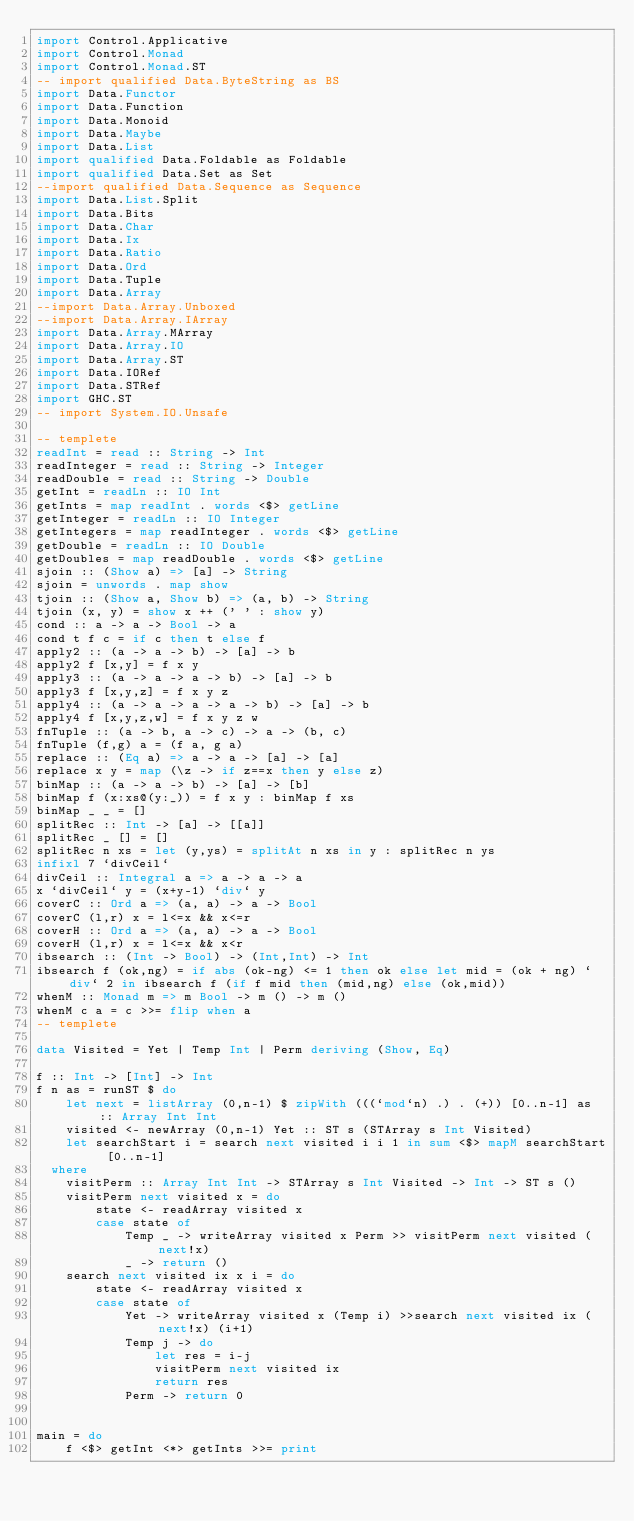Convert code to text. <code><loc_0><loc_0><loc_500><loc_500><_Haskell_>import Control.Applicative
import Control.Monad
import Control.Monad.ST
-- import qualified Data.ByteString as BS
import Data.Functor
import Data.Function
import Data.Monoid
import Data.Maybe
import Data.List
import qualified Data.Foldable as Foldable
import qualified Data.Set as Set
--import qualified Data.Sequence as Sequence
import Data.List.Split
import Data.Bits
import Data.Char
import Data.Ix
import Data.Ratio
import Data.Ord
import Data.Tuple
import Data.Array
--import Data.Array.Unboxed
--import Data.Array.IArray
import Data.Array.MArray
import Data.Array.IO
import Data.Array.ST
import Data.IORef
import Data.STRef
import GHC.ST
-- import System.IO.Unsafe
 
-- templete
readInt = read :: String -> Int
readInteger = read :: String -> Integer
readDouble = read :: String -> Double
getInt = readLn :: IO Int
getInts = map readInt . words <$> getLine
getInteger = readLn :: IO Integer
getIntegers = map readInteger . words <$> getLine
getDouble = readLn :: IO Double
getDoubles = map readDouble . words <$> getLine
sjoin :: (Show a) => [a] -> String
sjoin = unwords . map show
tjoin :: (Show a, Show b) => (a, b) -> String
tjoin (x, y) = show x ++ (' ' : show y)
cond :: a -> a -> Bool -> a
cond t f c = if c then t else f
apply2 :: (a -> a -> b) -> [a] -> b
apply2 f [x,y] = f x y
apply3 :: (a -> a -> a -> b) -> [a] -> b
apply3 f [x,y,z] = f x y z
apply4 :: (a -> a -> a -> a -> b) -> [a] -> b
apply4 f [x,y,z,w] = f x y z w
fnTuple :: (a -> b, a -> c) -> a -> (b, c)
fnTuple (f,g) a = (f a, g a)
replace :: (Eq a) => a -> a -> [a] -> [a]
replace x y = map (\z -> if z==x then y else z)
binMap :: (a -> a -> b) -> [a] -> [b]
binMap f (x:xs@(y:_)) = f x y : binMap f xs
binMap _ _ = []
splitRec :: Int -> [a] -> [[a]]
splitRec _ [] = []
splitRec n xs = let (y,ys) = splitAt n xs in y : splitRec n ys
infixl 7 `divCeil`
divCeil :: Integral a => a -> a -> a
x `divCeil` y = (x+y-1) `div` y
coverC :: Ord a => (a, a) -> a -> Bool
coverC (l,r) x = l<=x && x<=r
coverH :: Ord a => (a, a) -> a -> Bool
coverH (l,r) x = l<=x && x<r
ibsearch :: (Int -> Bool) -> (Int,Int) -> Int
ibsearch f (ok,ng) = if abs (ok-ng) <= 1 then ok else let mid = (ok + ng) `div` 2 in ibsearch f (if f mid then (mid,ng) else (ok,mid))
whenM :: Monad m => m Bool -> m () -> m ()
whenM c a = c >>= flip when a
-- templete

data Visited = Yet | Temp Int | Perm deriving (Show, Eq)

f :: Int -> [Int] -> Int
f n as = runST $ do
    let next = listArray (0,n-1) $ zipWith (((`mod`n) .) . (+)) [0..n-1] as :: Array Int Int
    visited <- newArray (0,n-1) Yet :: ST s (STArray s Int Visited)
    let searchStart i = search next visited i i 1 in sum <$> mapM searchStart [0..n-1]
  where
    visitPerm :: Array Int Int -> STArray s Int Visited -> Int -> ST s ()
    visitPerm next visited x = do
        state <- readArray visited x
        case state of
            Temp _ -> writeArray visited x Perm >> visitPerm next visited (next!x)
            _ -> return ()
    search next visited ix x i = do
        state <- readArray visited x
        case state of
            Yet -> writeArray visited x (Temp i) >>search next visited ix (next!x) (i+1)
            Temp j -> do
                let res = i-j
                visitPerm next visited ix
                return res
            Perm -> return 0


main = do
    f <$> getInt <*> getInts >>= print

</code> 